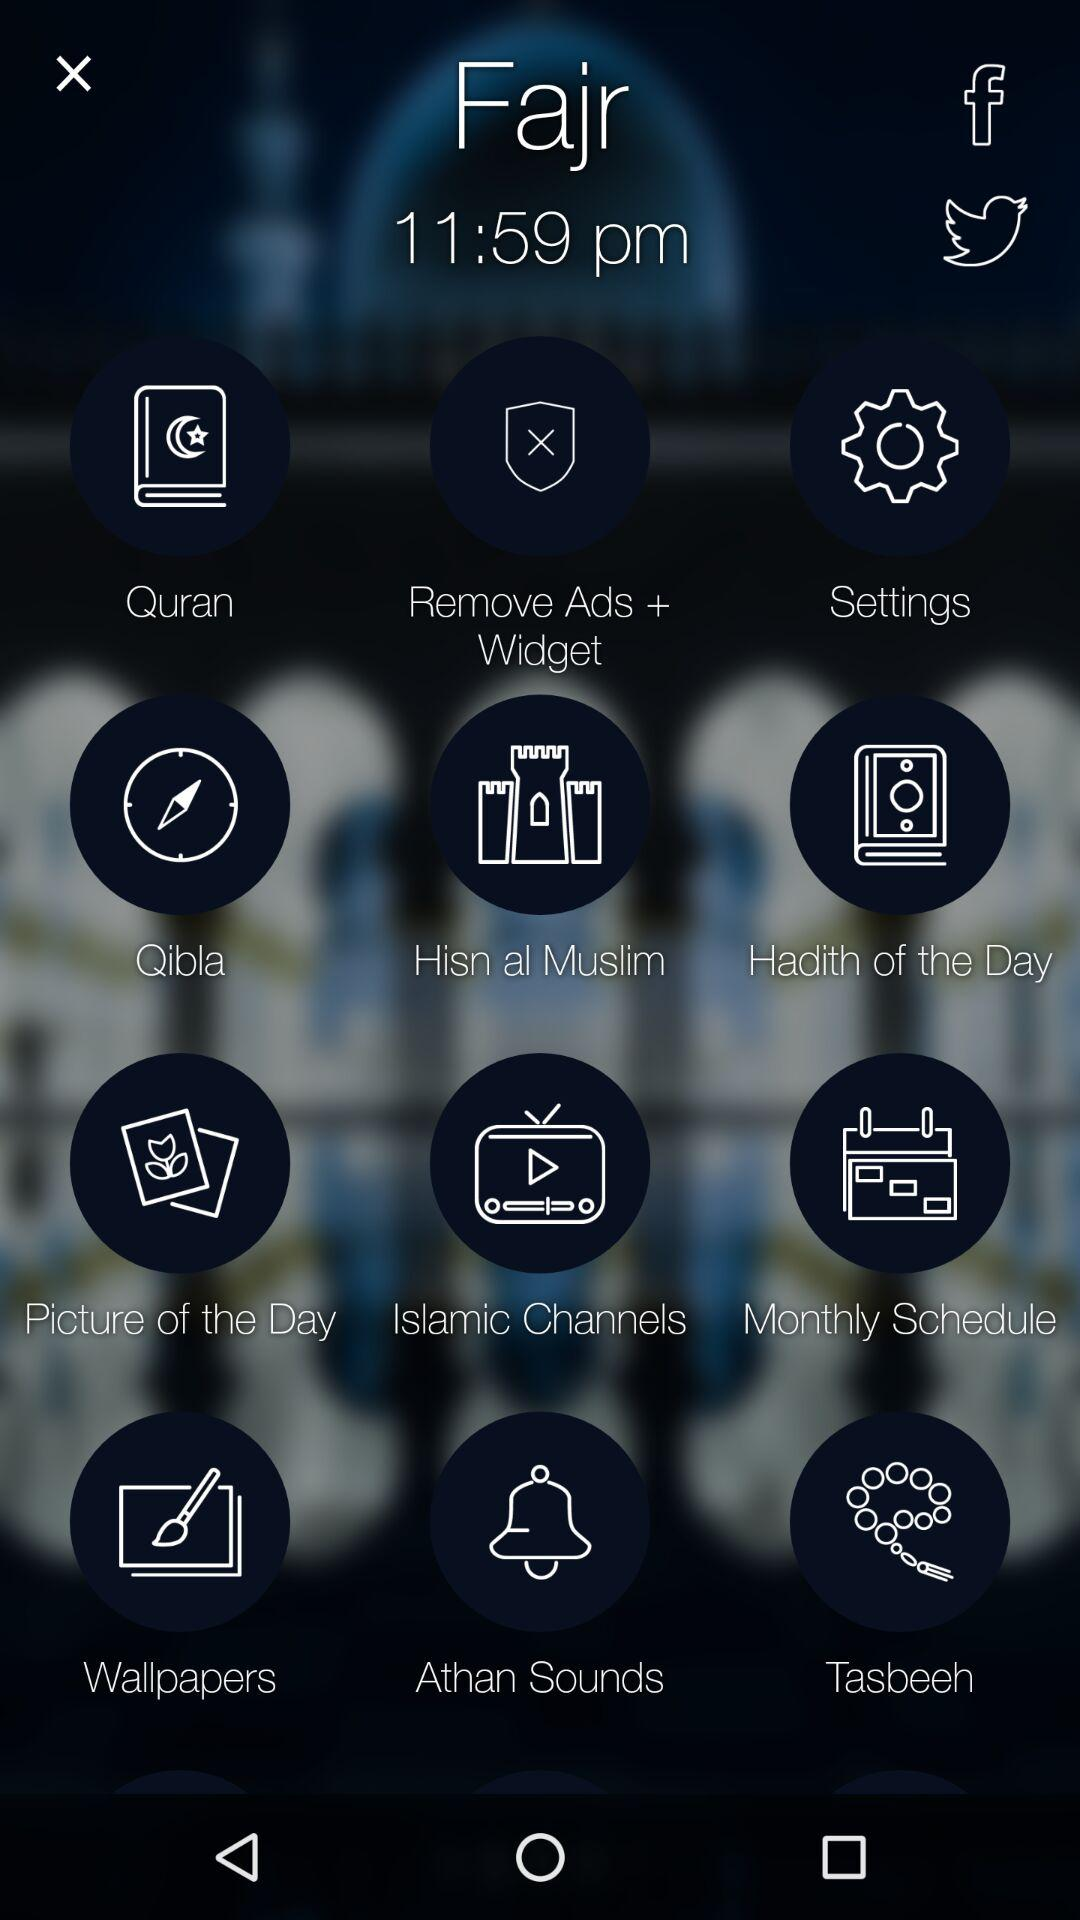What is the fajr time? The fajr time is 11:59 pm. 